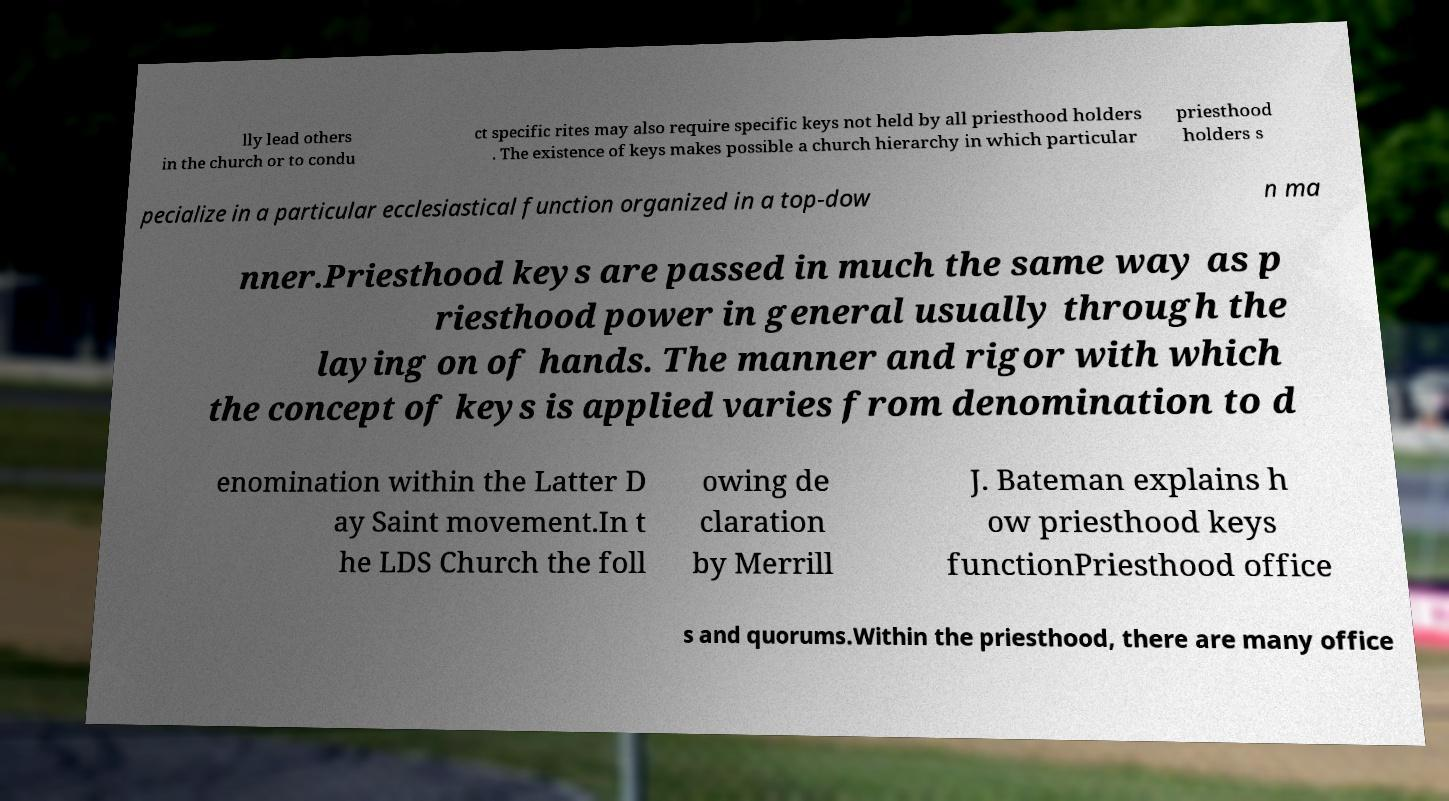Could you assist in decoding the text presented in this image and type it out clearly? lly lead others in the church or to condu ct specific rites may also require specific keys not held by all priesthood holders . The existence of keys makes possible a church hierarchy in which particular priesthood holders s pecialize in a particular ecclesiastical function organized in a top-dow n ma nner.Priesthood keys are passed in much the same way as p riesthood power in general usually through the laying on of hands. The manner and rigor with which the concept of keys is applied varies from denomination to d enomination within the Latter D ay Saint movement.In t he LDS Church the foll owing de claration by Merrill J. Bateman explains h ow priesthood keys functionPriesthood office s and quorums.Within the priesthood, there are many office 